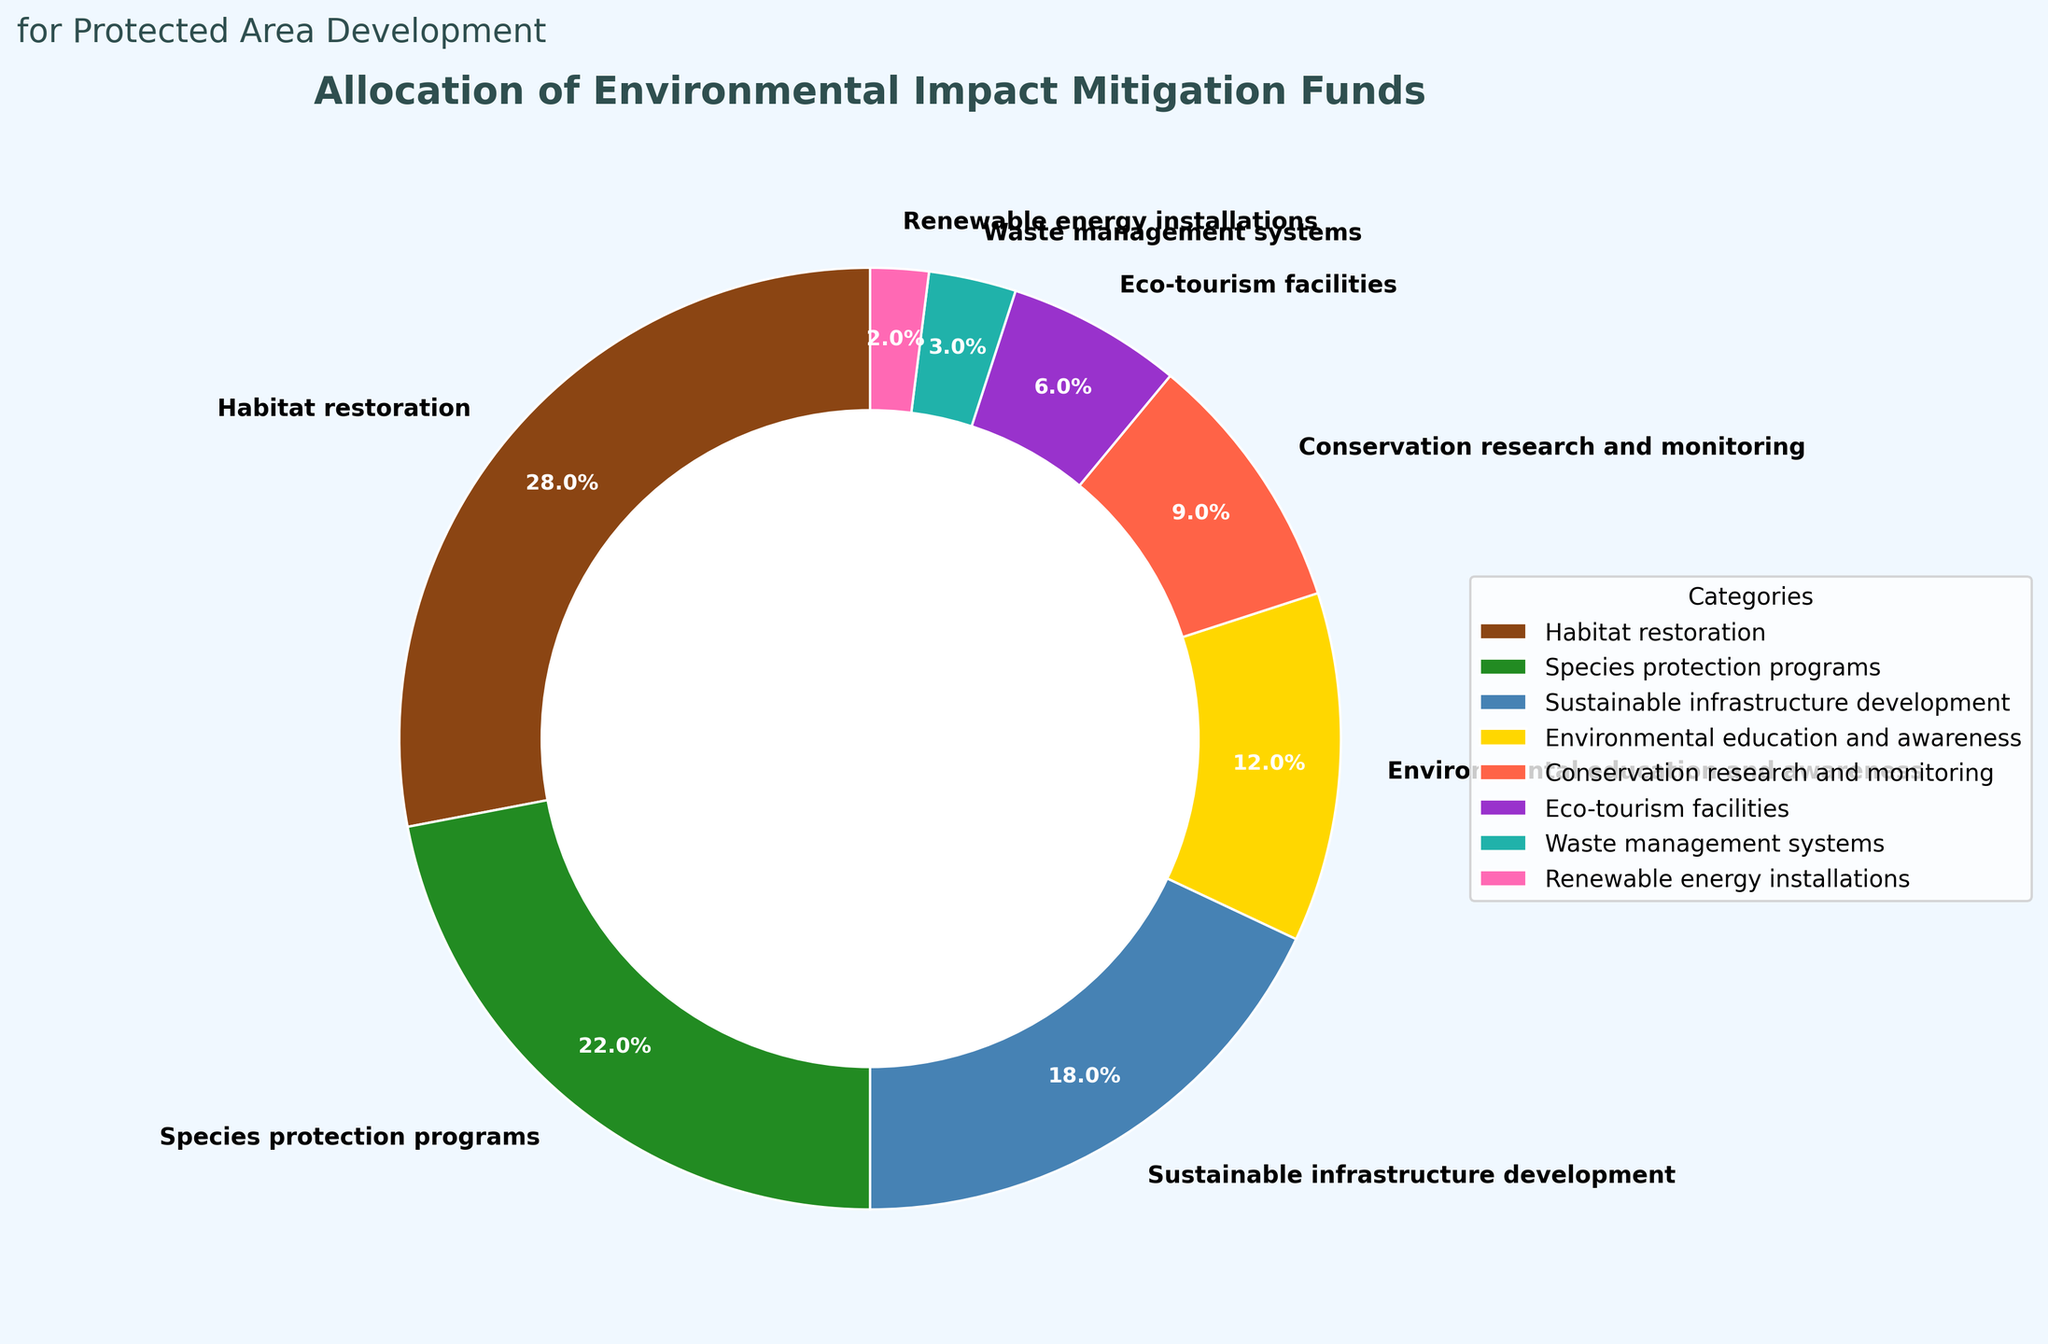What percentage of the funds is allocated to species protection programs and waste management systems combined? Add the percentages for species protection programs (22) and waste management systems (3): 22 + 3 = 25
Answer: 25 Which category has the smallest allocation, and what is its percentage? Look for the category with the smallest percentage value. Renewable energy installations have the smallest value at 2%.
Answer: Renewable energy installations, 2% How much more is allocated to habitat restoration than to eco-tourism facilities? Subtract the percentage for eco-tourism facilities (6) from the percentage for habitat restoration (28): 28 - 6 = 22
Answer: 22 Is the allocation for conservation research and monitoring greater than that for environmental education and awareness? Compare the percentages. Conservation research and monitoring is 9%, and environmental education and awareness is 12%, so 9% is not greater than 12%.
Answer: No What is the sum of the allocations for sustainable infrastructure development, eco-tourism facilities, and renewable energy installations? Add the percentages for sustainable infrastructure development (18), eco-tourism facilities (6), and renewable energy installations (2): 18 + 6 + 2 = 26
Answer: 26 Which category has a greater allocation: conservation research and monitoring or eco-tourism facilities? Compare the percentages. Conservation research and monitoring is 9%, and eco-tourism facilities is 6%, so conservation research and monitoring is greater.
Answer: Conservation research and monitoring What is the average allocation percentage for all the categories listed? Sum all the percentages and divide by the number of categories: (28 + 22 + 18 + 12 + 9 + 6 + 3 + 2) / 8 = 100 / 8 = 12.5
Answer: 12.5 In terms of allocation, is the category with the second highest percentage closer to the highest or the third highest category? The highest allocation is habitat restoration (28%), the second highest is species protection programs (22%), and the third highest is sustainable infrastructure development (18%). The difference between the highest and second highest is 28 - 22 = 6, and the difference between the second and third highest is 22 - 18 = 4. So, the second highest is closer to the third.
Answer: Closer to the third highest 